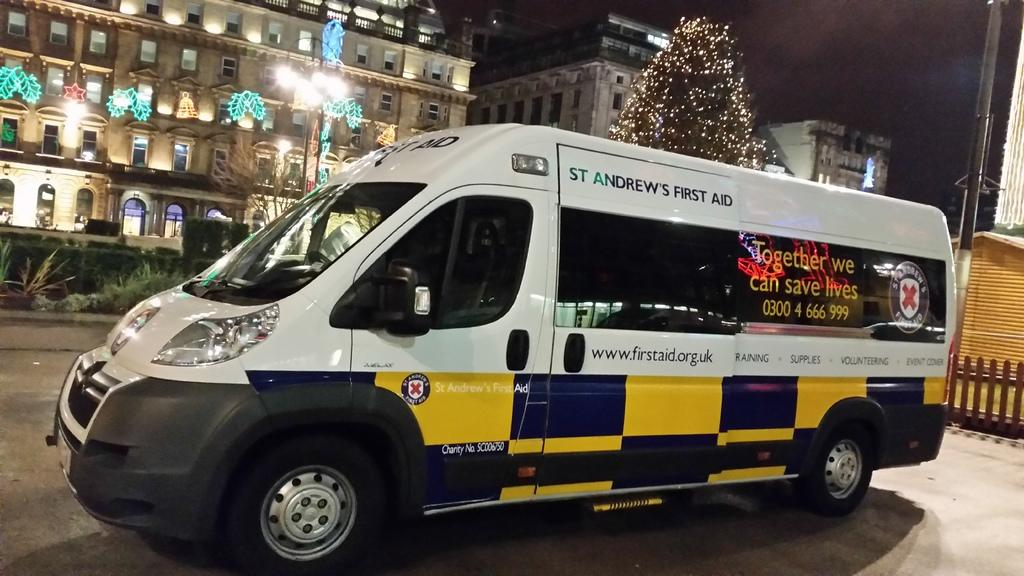<image>
Relay a brief, clear account of the picture shown. A yellow, white and black van with St. Andrews first aid written on the side. 